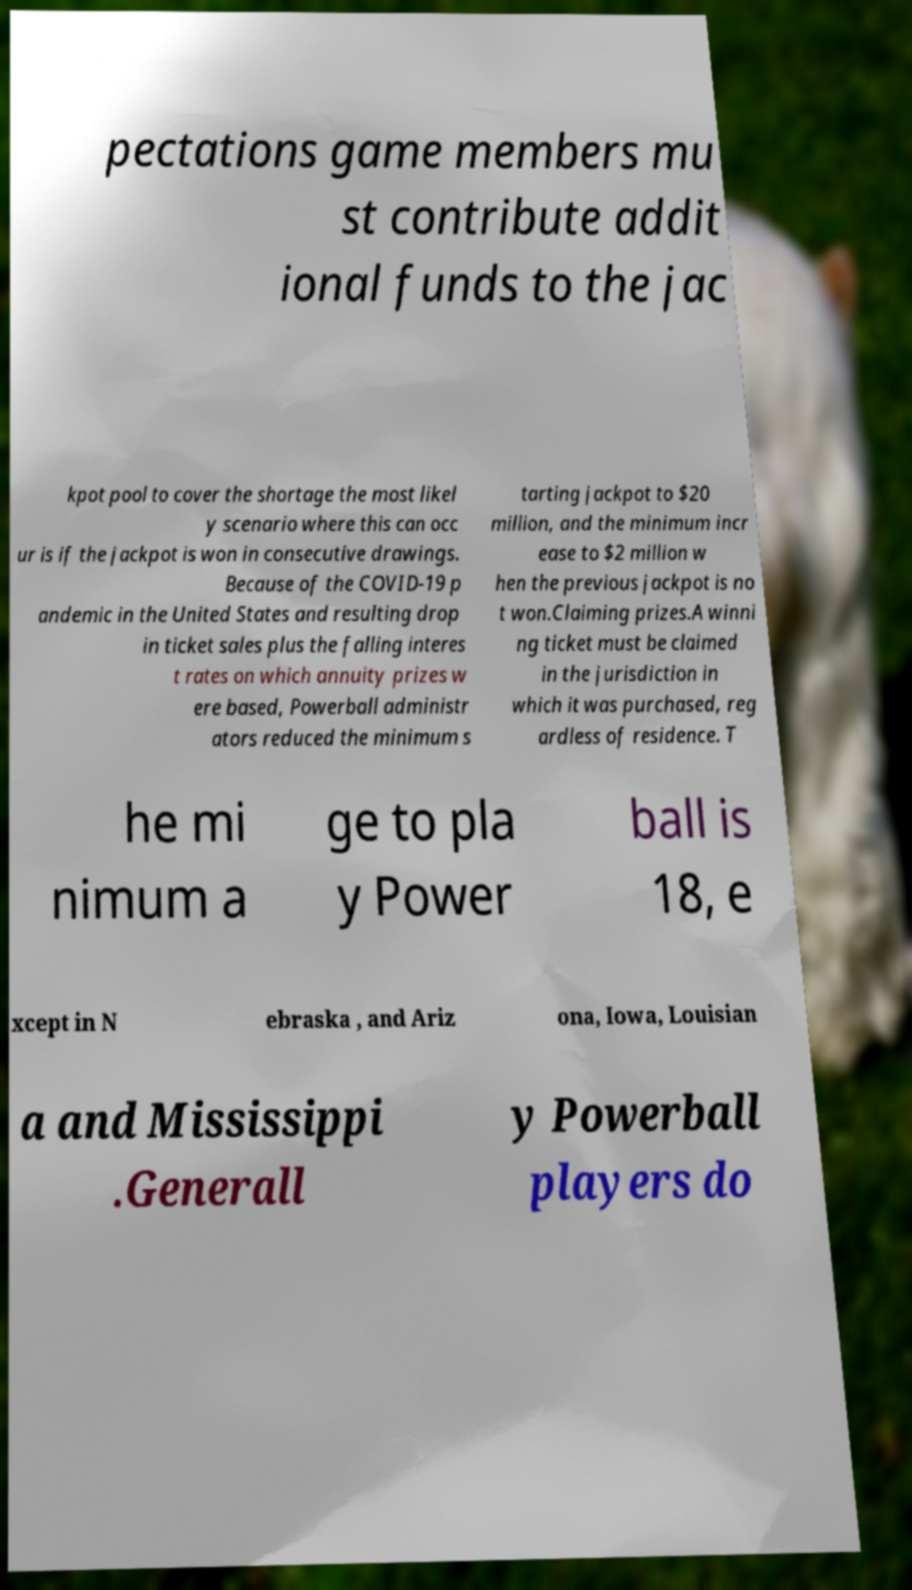Could you assist in decoding the text presented in this image and type it out clearly? pectations game members mu st contribute addit ional funds to the jac kpot pool to cover the shortage the most likel y scenario where this can occ ur is if the jackpot is won in consecutive drawings. Because of the COVID-19 p andemic in the United States and resulting drop in ticket sales plus the falling interes t rates on which annuity prizes w ere based, Powerball administr ators reduced the minimum s tarting jackpot to $20 million, and the minimum incr ease to $2 million w hen the previous jackpot is no t won.Claiming prizes.A winni ng ticket must be claimed in the jurisdiction in which it was purchased, reg ardless of residence. T he mi nimum a ge to pla y Power ball is 18, e xcept in N ebraska , and Ariz ona, Iowa, Louisian a and Mississippi .Generall y Powerball players do 